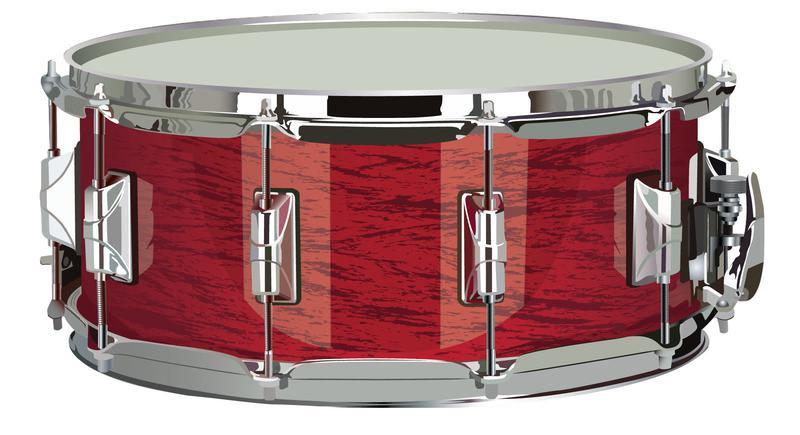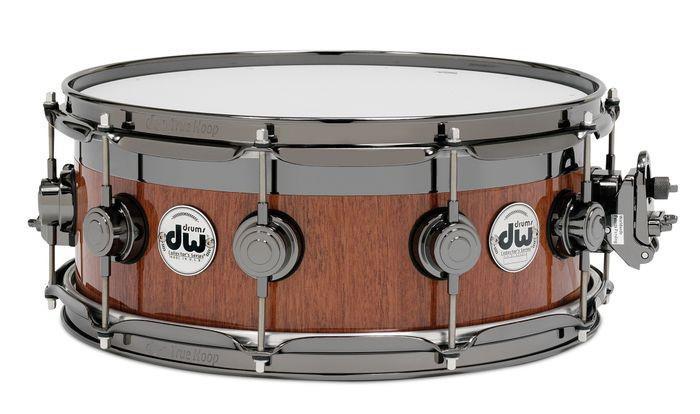The first image is the image on the left, the second image is the image on the right. For the images displayed, is the sentence "The drum on the left has a red exterior with rectangular silver shapes spaced around it, and the drum on the right is brown with round shapes spaced around it." factually correct? Answer yes or no. Yes. 